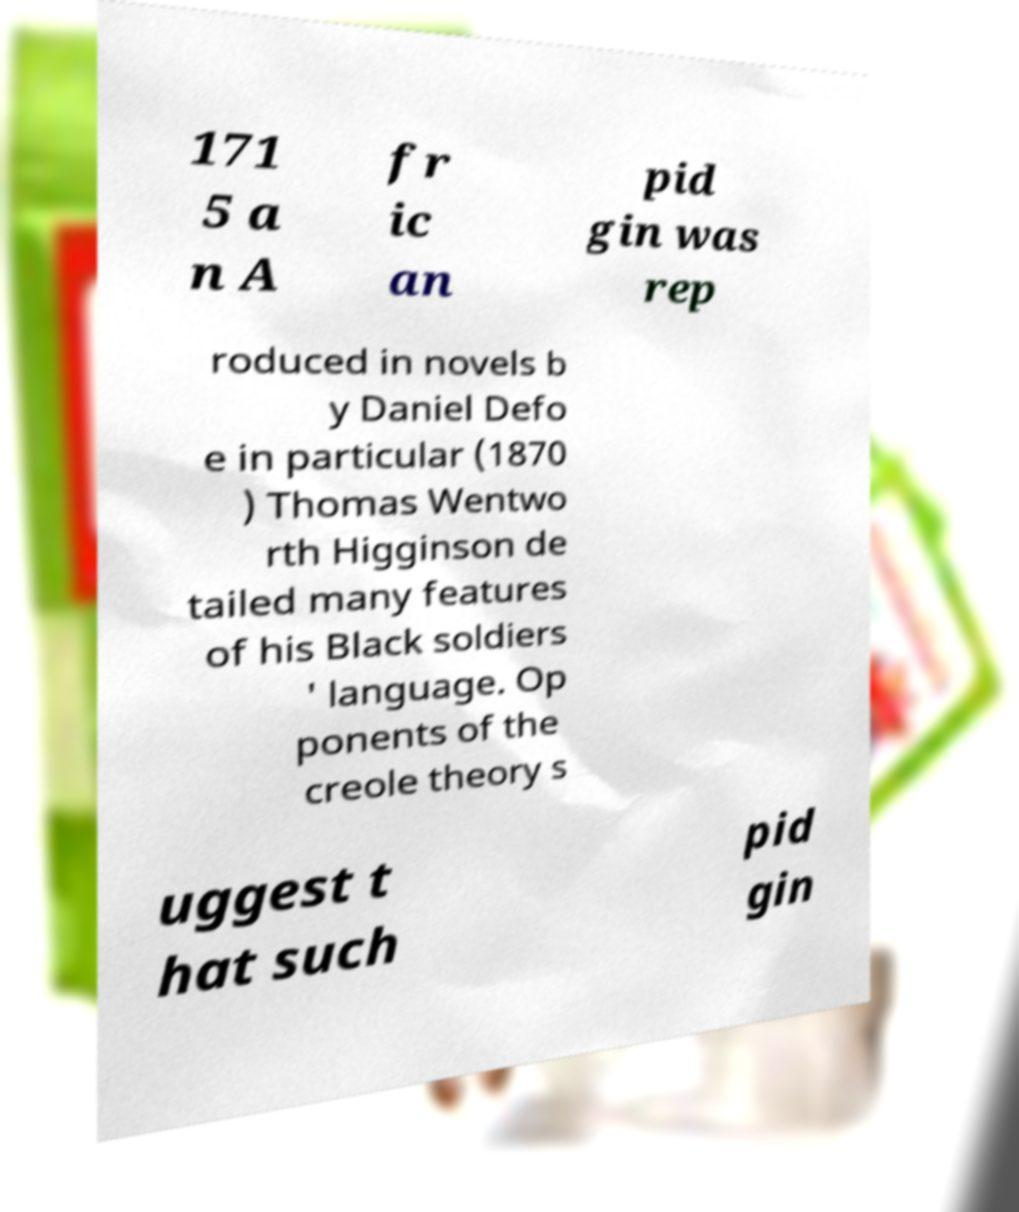Could you extract and type out the text from this image? 171 5 a n A fr ic an pid gin was rep roduced in novels b y Daniel Defo e in particular (1870 ) Thomas Wentwo rth Higginson de tailed many features of his Black soldiers ' language. Op ponents of the creole theory s uggest t hat such pid gin 